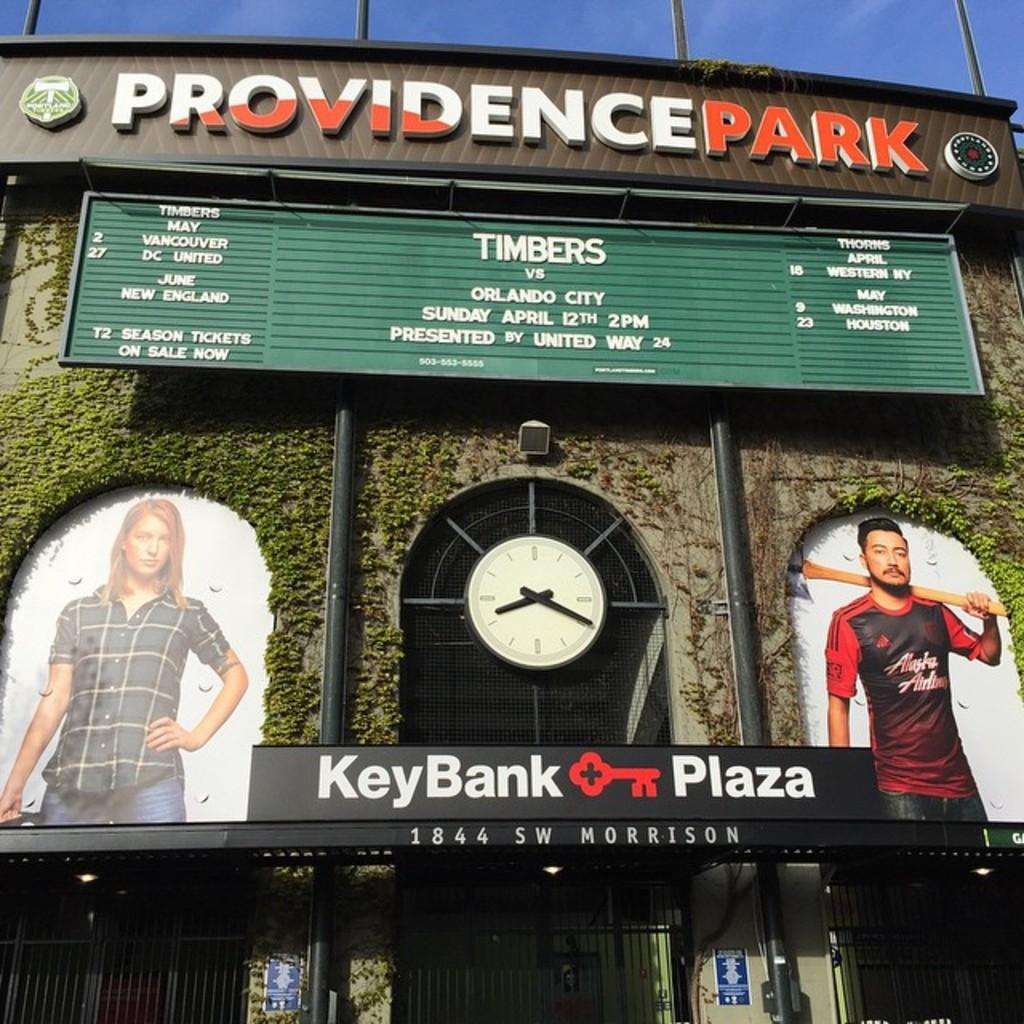<image>
Render a clear and concise summary of the photo. The sign at Providence Park shows that the Timbers will be playing Orlando City on April 12th at 2pm. 